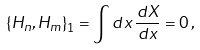<formula> <loc_0><loc_0><loc_500><loc_500>\left \{ H _ { n } , H _ { m } \right \} _ { 1 } = \int d x \, \frac { d X } { d x } = 0 \, ,</formula> 